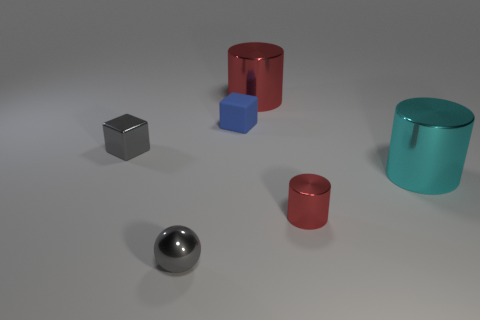What could be the use of these objects? These objects seem to be simplistic representations used in a 3D render, likely for artistic or illustrative purposes. They might serve as placeholders or examples in a graphic design or a 3D modeling software tutorial. 